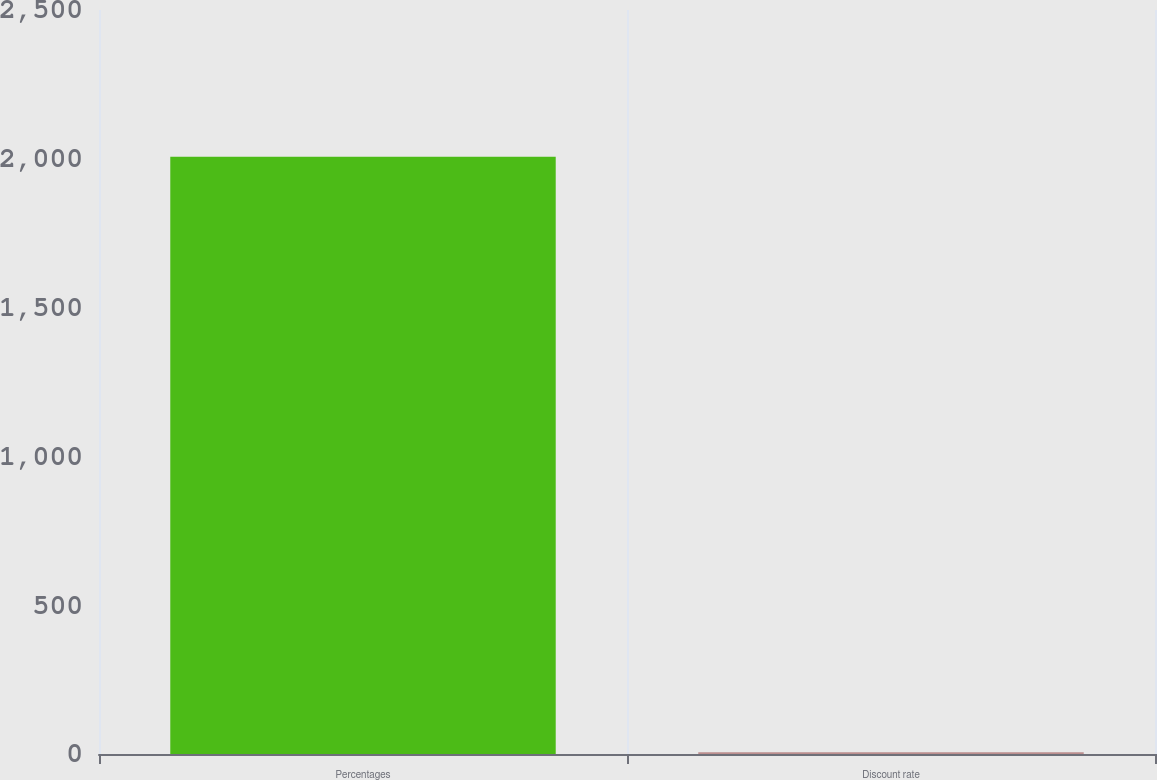Convert chart. <chart><loc_0><loc_0><loc_500><loc_500><bar_chart><fcel>Percentages<fcel>Discount rate<nl><fcel>2007<fcel>6<nl></chart> 